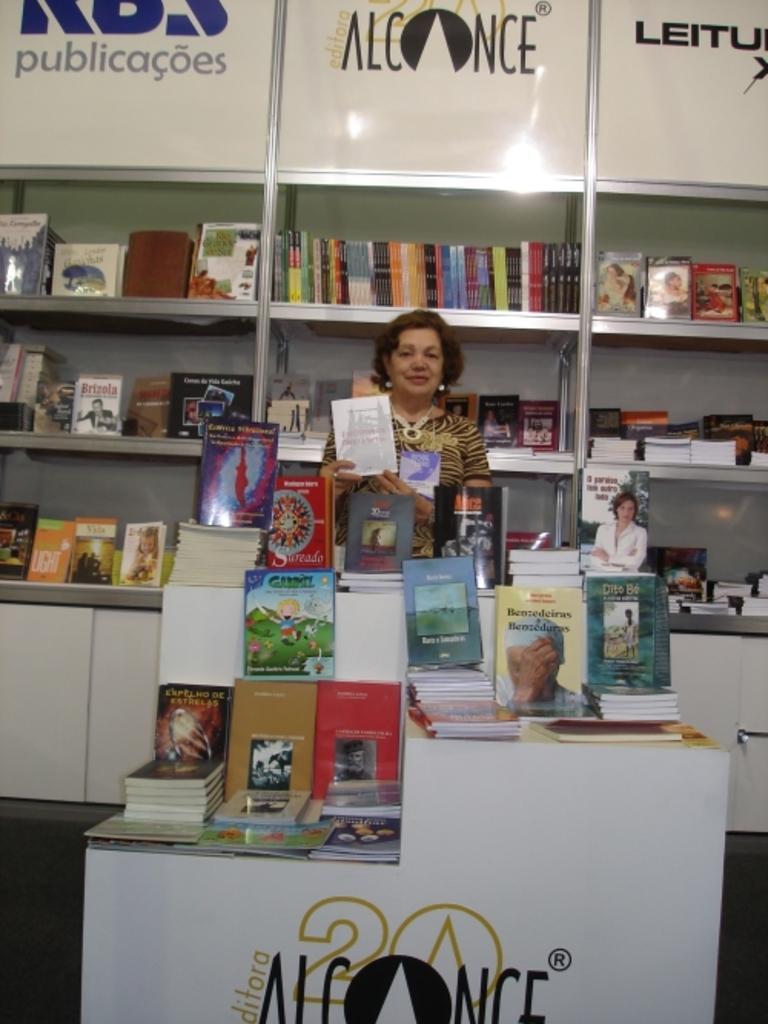In one or two sentences, can you explain what this image depicts? In this image I can see number of books in the front and in the background. On the top of this image and on the bottom side I can see something is written. In the center of this image I can see a woman and I can see she is holding a book. 